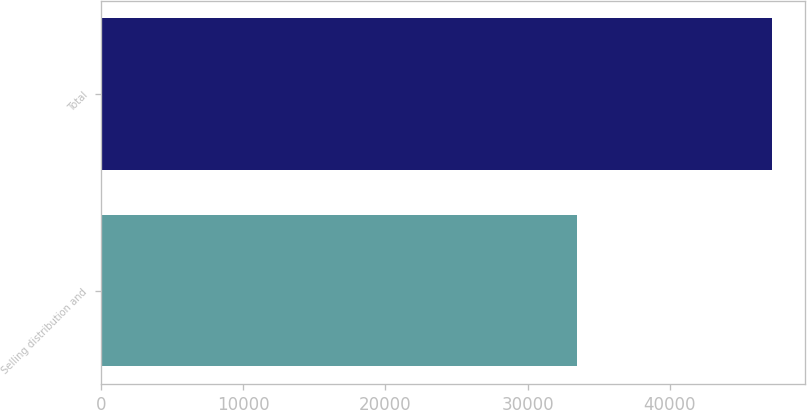Convert chart. <chart><loc_0><loc_0><loc_500><loc_500><bar_chart><fcel>Selling distribution and<fcel>Total<nl><fcel>33463<fcel>47176<nl></chart> 